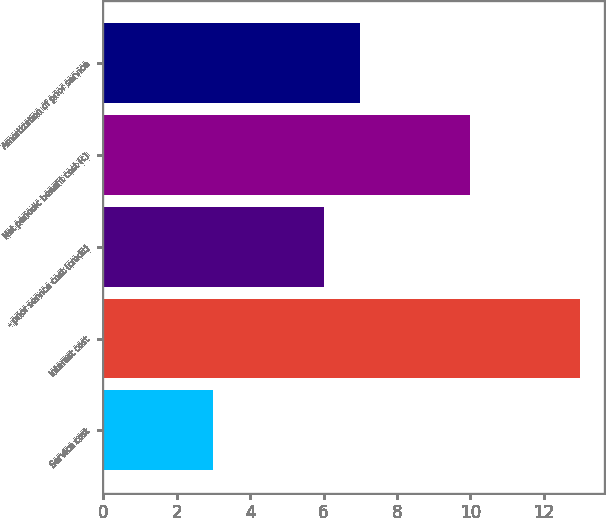Convert chart to OTSL. <chart><loc_0><loc_0><loc_500><loc_500><bar_chart><fcel>Service cost<fcel>Interest cost<fcel>- prior service cost (credit)<fcel>Net periodic benefit cost (c)<fcel>Amortization of prior service<nl><fcel>3<fcel>13<fcel>6<fcel>10<fcel>7<nl></chart> 